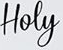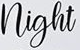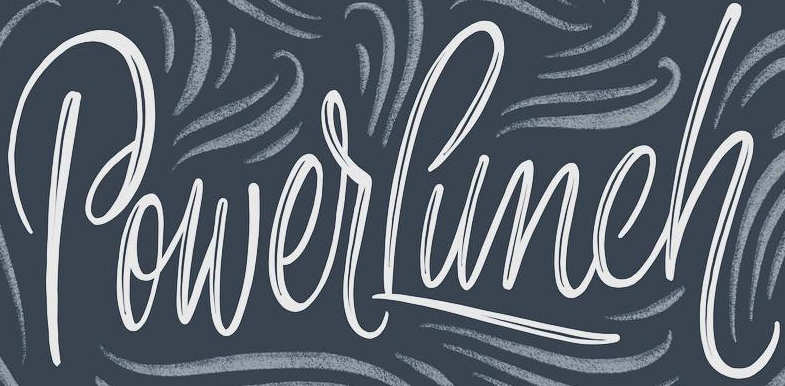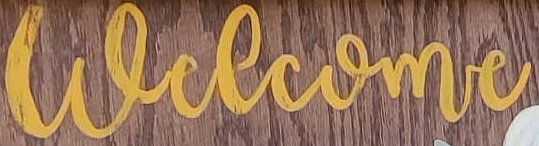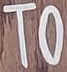What words are shown in these images in order, separated by a semicolon? Hoey; night; PowerLunch; welcome; TO 